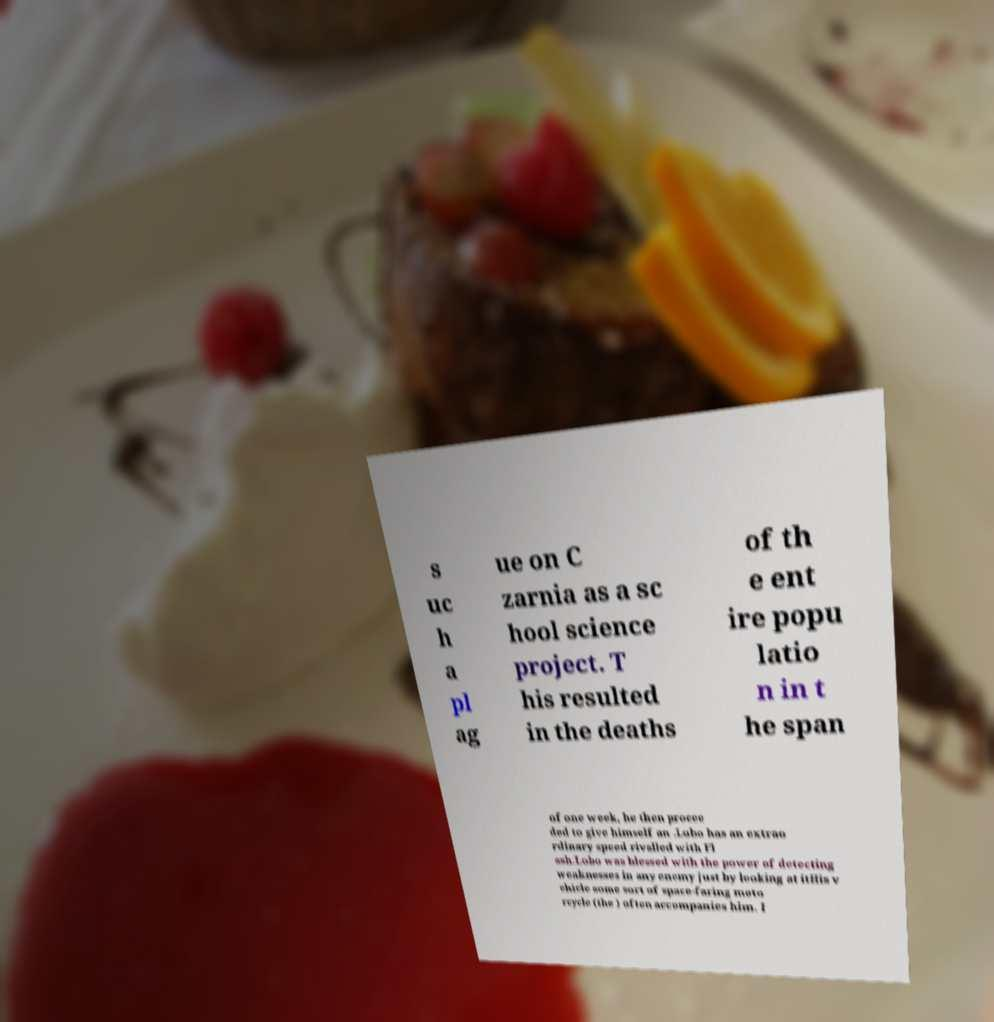I need the written content from this picture converted into text. Can you do that? s uc h a pl ag ue on C zarnia as a sc hool science project. T his resulted in the deaths of th e ent ire popu latio n in t he span of one week, he then procee ded to give himself an .Lobo has an extrao rdinary speed rivalled with Fl ash.Lobo was blessed with the power of detecting weaknesses in any enemy just by looking at itHis v ehicle some sort of space-faring moto rcycle (the ) often accompanies him. I 